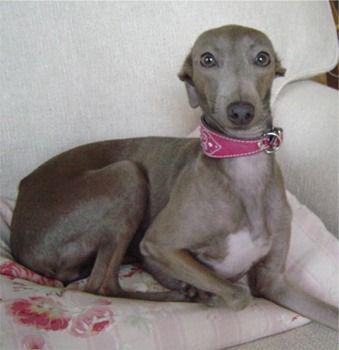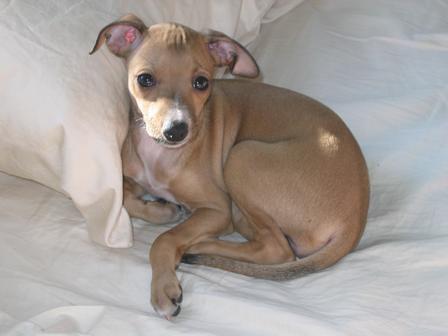The first image is the image on the left, the second image is the image on the right. For the images displayed, is the sentence "There is a dog with a solid gray face in one of the images." factually correct? Answer yes or no. Yes. The first image is the image on the left, the second image is the image on the right. Examine the images to the left and right. Is the description "Exactly one of the dogs is standing, and it is posed on green grass with body in profile." accurate? Answer yes or no. No. 